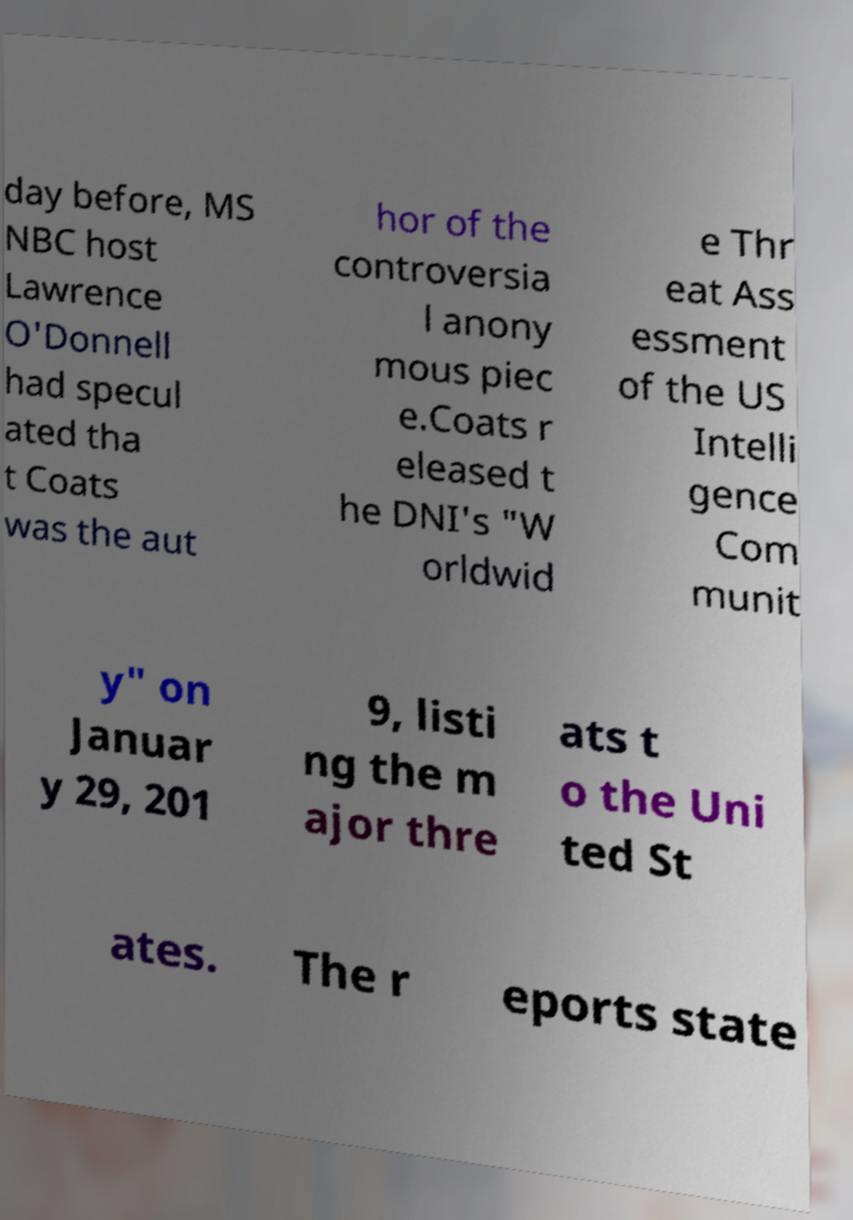Can you read and provide the text displayed in the image?This photo seems to have some interesting text. Can you extract and type it out for me? day before, MS NBC host Lawrence O'Donnell had specul ated tha t Coats was the aut hor of the controversia l anony mous piec e.Coats r eleased t he DNI's "W orldwid e Thr eat Ass essment of the US Intelli gence Com munit y" on Januar y 29, 201 9, listi ng the m ajor thre ats t o the Uni ted St ates. The r eports state 